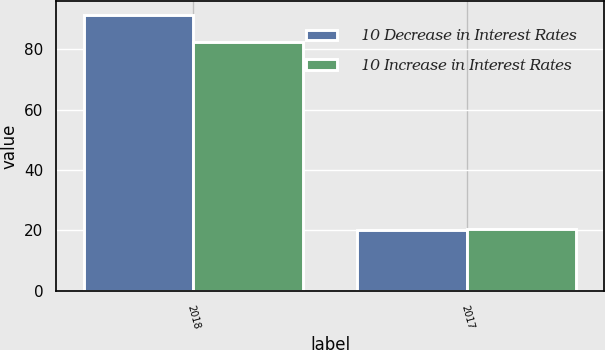Convert chart. <chart><loc_0><loc_0><loc_500><loc_500><stacked_bar_chart><ecel><fcel>2018<fcel>2017<nl><fcel>10 Decrease in Interest Rates<fcel>91.3<fcel>20.2<nl><fcel>10 Increase in Interest Rates<fcel>82.5<fcel>20.6<nl></chart> 